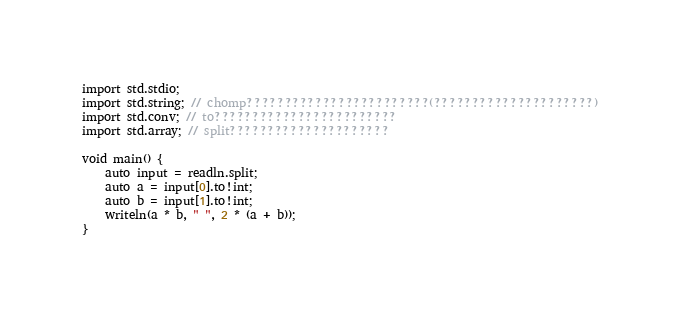<code> <loc_0><loc_0><loc_500><loc_500><_D_>
import std.stdio;
import std.string; // chomp????????????????????????(?????????????????????)
import std.conv; // to????????????????????????
import std.array; // split?????????????????????

void main() {
    auto input = readln.split;
    auto a = input[0].to!int;
    auto b = input[1].to!int;
    writeln(a * b, " ", 2 * (a + b));
}</code> 